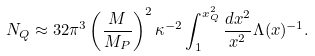Convert formula to latex. <formula><loc_0><loc_0><loc_500><loc_500>N _ { Q } \approx 3 2 \pi ^ { 3 } \left ( \frac { M } { M _ { P } } \right ) ^ { 2 } \kappa ^ { - 2 } \int _ { 1 } ^ { x _ { Q } ^ { 2 } } \frac { d x ^ { 2 } } { x ^ { 2 } } \Lambda ( x ) ^ { - 1 } .</formula> 